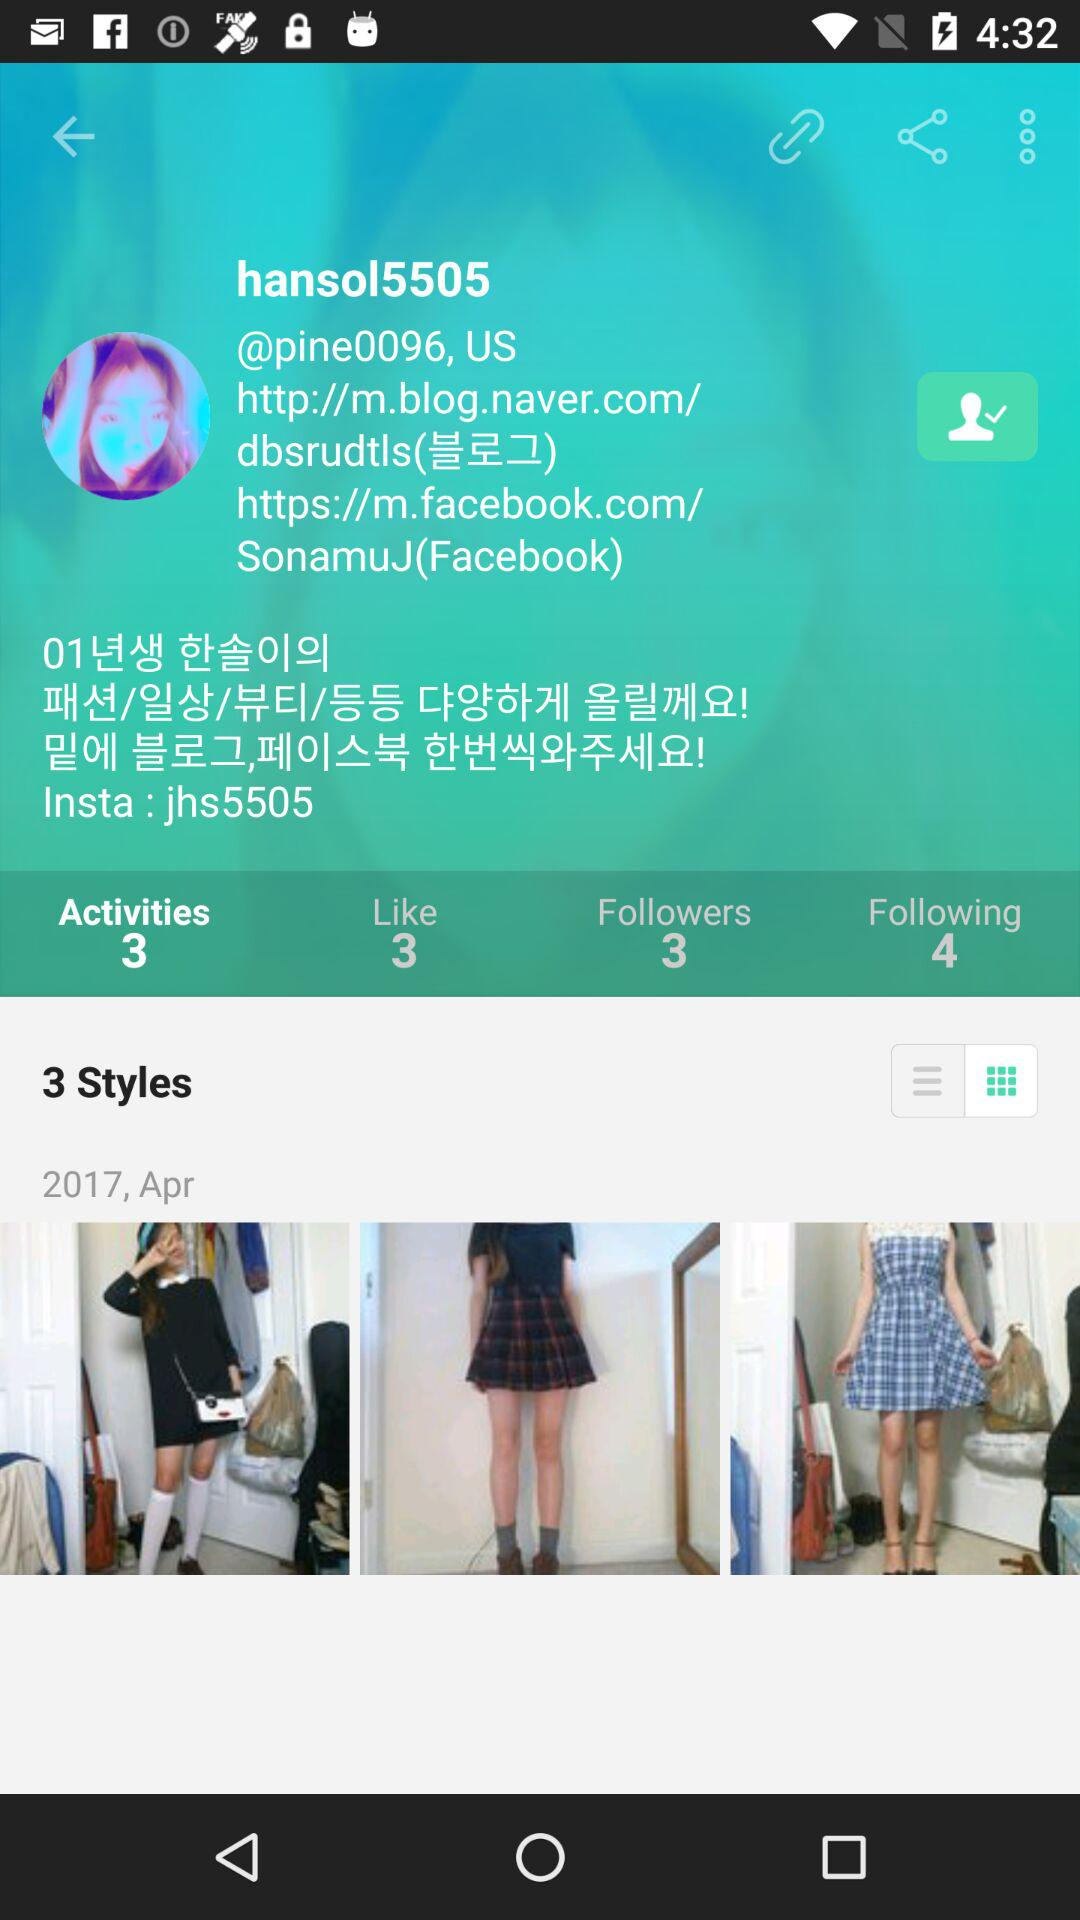What is the username? The username is "hansol5505". 